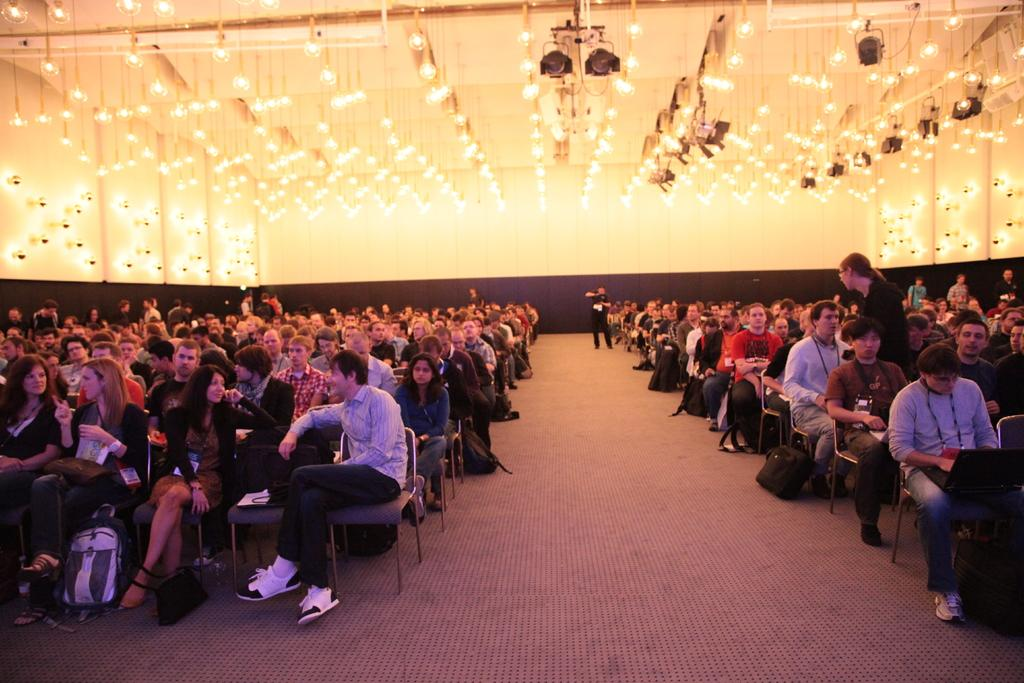What type of space is depicted in the image? There is a hall in the image. What are the people in the hall doing? The people are sitting on chairs in chairs in the hall. What can be seen in the image that provides illumination? There are lights visible in the image. Can you tell me how many clams are sitting on the chairs in the image? There are no clams present in the image; the people sitting on the chairs are human. What type of approval is being given in the image? There is no indication of any approval being given in the image; it simply shows a hall with people sitting on chairs. 